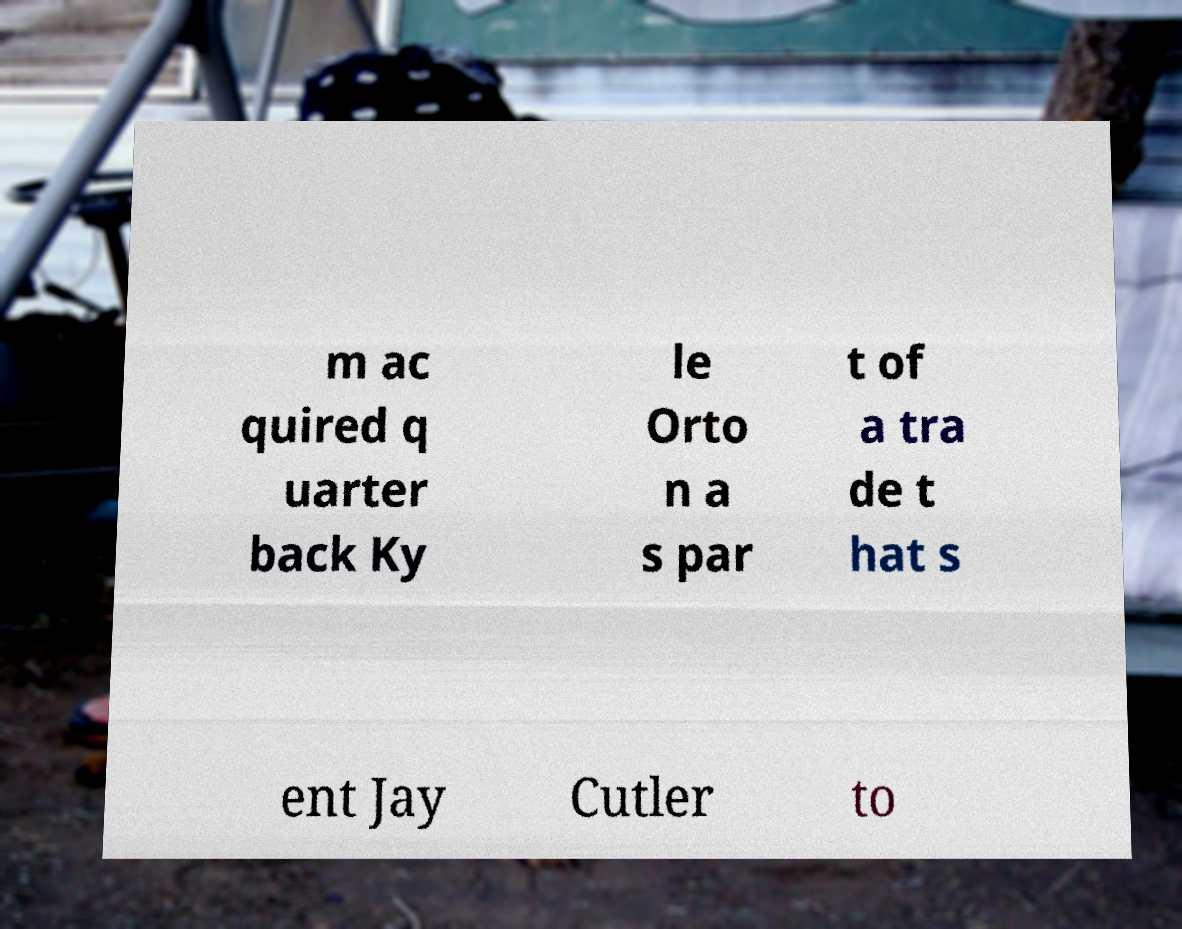Please read and relay the text visible in this image. What does it say? m ac quired q uarter back Ky le Orto n a s par t of a tra de t hat s ent Jay Cutler to 